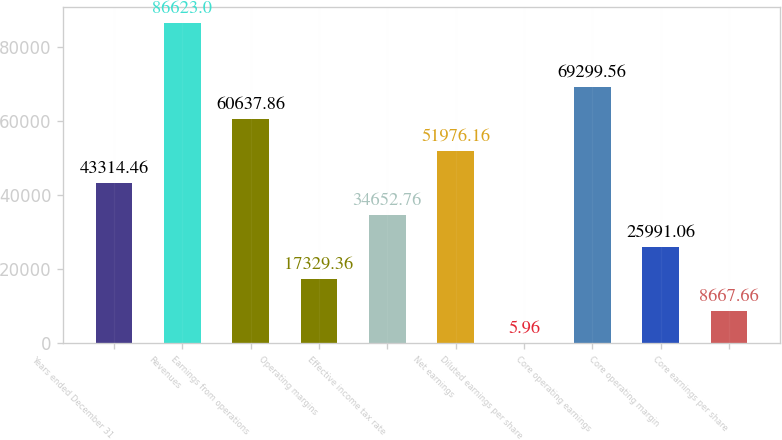<chart> <loc_0><loc_0><loc_500><loc_500><bar_chart><fcel>Years ended December 31<fcel>Revenues<fcel>Earnings from operations<fcel>Operating margins<fcel>Effective income tax rate<fcel>Net earnings<fcel>Diluted earnings per share<fcel>Core operating earnings<fcel>Core operating margin<fcel>Core earnings per share<nl><fcel>43314.5<fcel>86623<fcel>60637.9<fcel>17329.4<fcel>34652.8<fcel>51976.2<fcel>5.96<fcel>69299.6<fcel>25991.1<fcel>8667.66<nl></chart> 